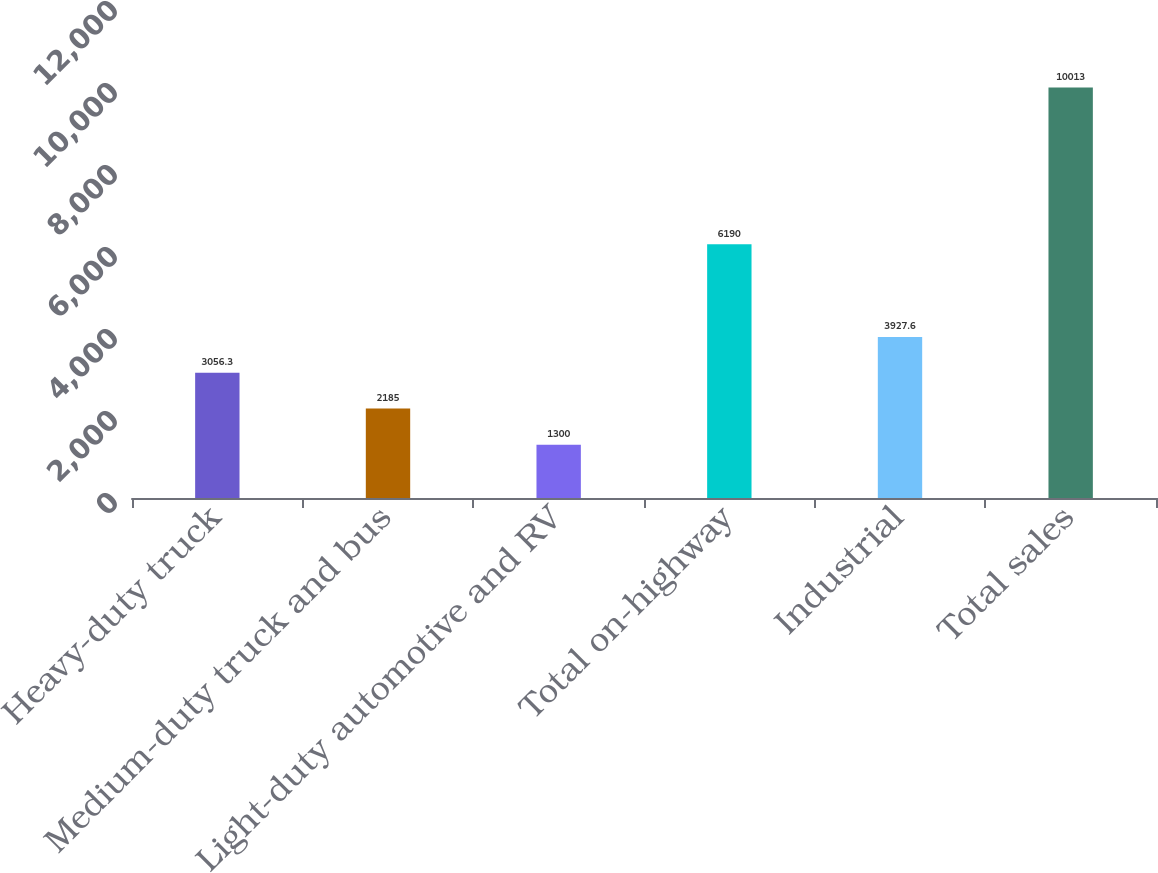Convert chart. <chart><loc_0><loc_0><loc_500><loc_500><bar_chart><fcel>Heavy-duty truck<fcel>Medium-duty truck and bus<fcel>Light-duty automotive and RV<fcel>Total on-highway<fcel>Industrial<fcel>Total sales<nl><fcel>3056.3<fcel>2185<fcel>1300<fcel>6190<fcel>3927.6<fcel>10013<nl></chart> 